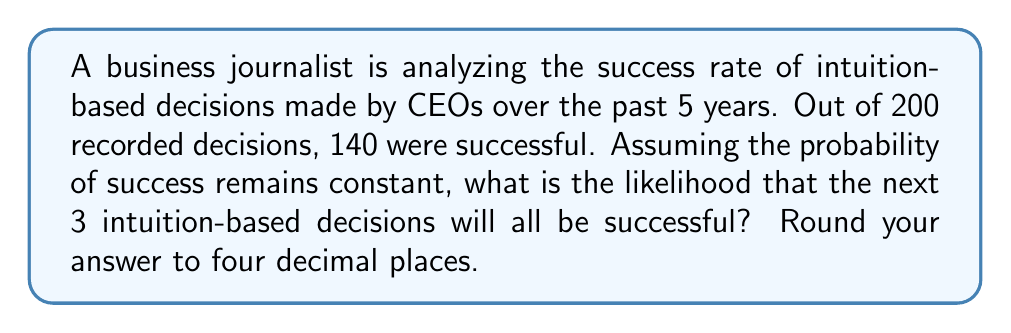Show me your answer to this math problem. To solve this problem, we'll follow these steps:

1. Calculate the probability of a single successful decision:
   $$P(\text{success}) = \frac{\text{Number of successful decisions}}{\text{Total number of decisions}}$$
   $$P(\text{success}) = \frac{140}{200} = 0.7$$

2. For the next 3 decisions to all be successful, we need to calculate the probability of success happening 3 times in a row. Since each decision is independent, we multiply the individual probabilities:
   $$P(\text{3 successes}) = P(\text{success})^3$$
   $$P(\text{3 successes}) = 0.7^3$$

3. Calculate the final result:
   $$P(\text{3 successes}) = 0.7^3 = 0.343$$

4. Round to four decimal places:
   $$P(\text{3 successes}) \approx 0.3430$$

This result suggests that while intuition-based decisions have been fairly successful in the past (70% success rate), the probability of making three correct decisions in a row is considerably lower, highlighting the importance of combining intuition with other decision-making tools.
Answer: 0.3430 